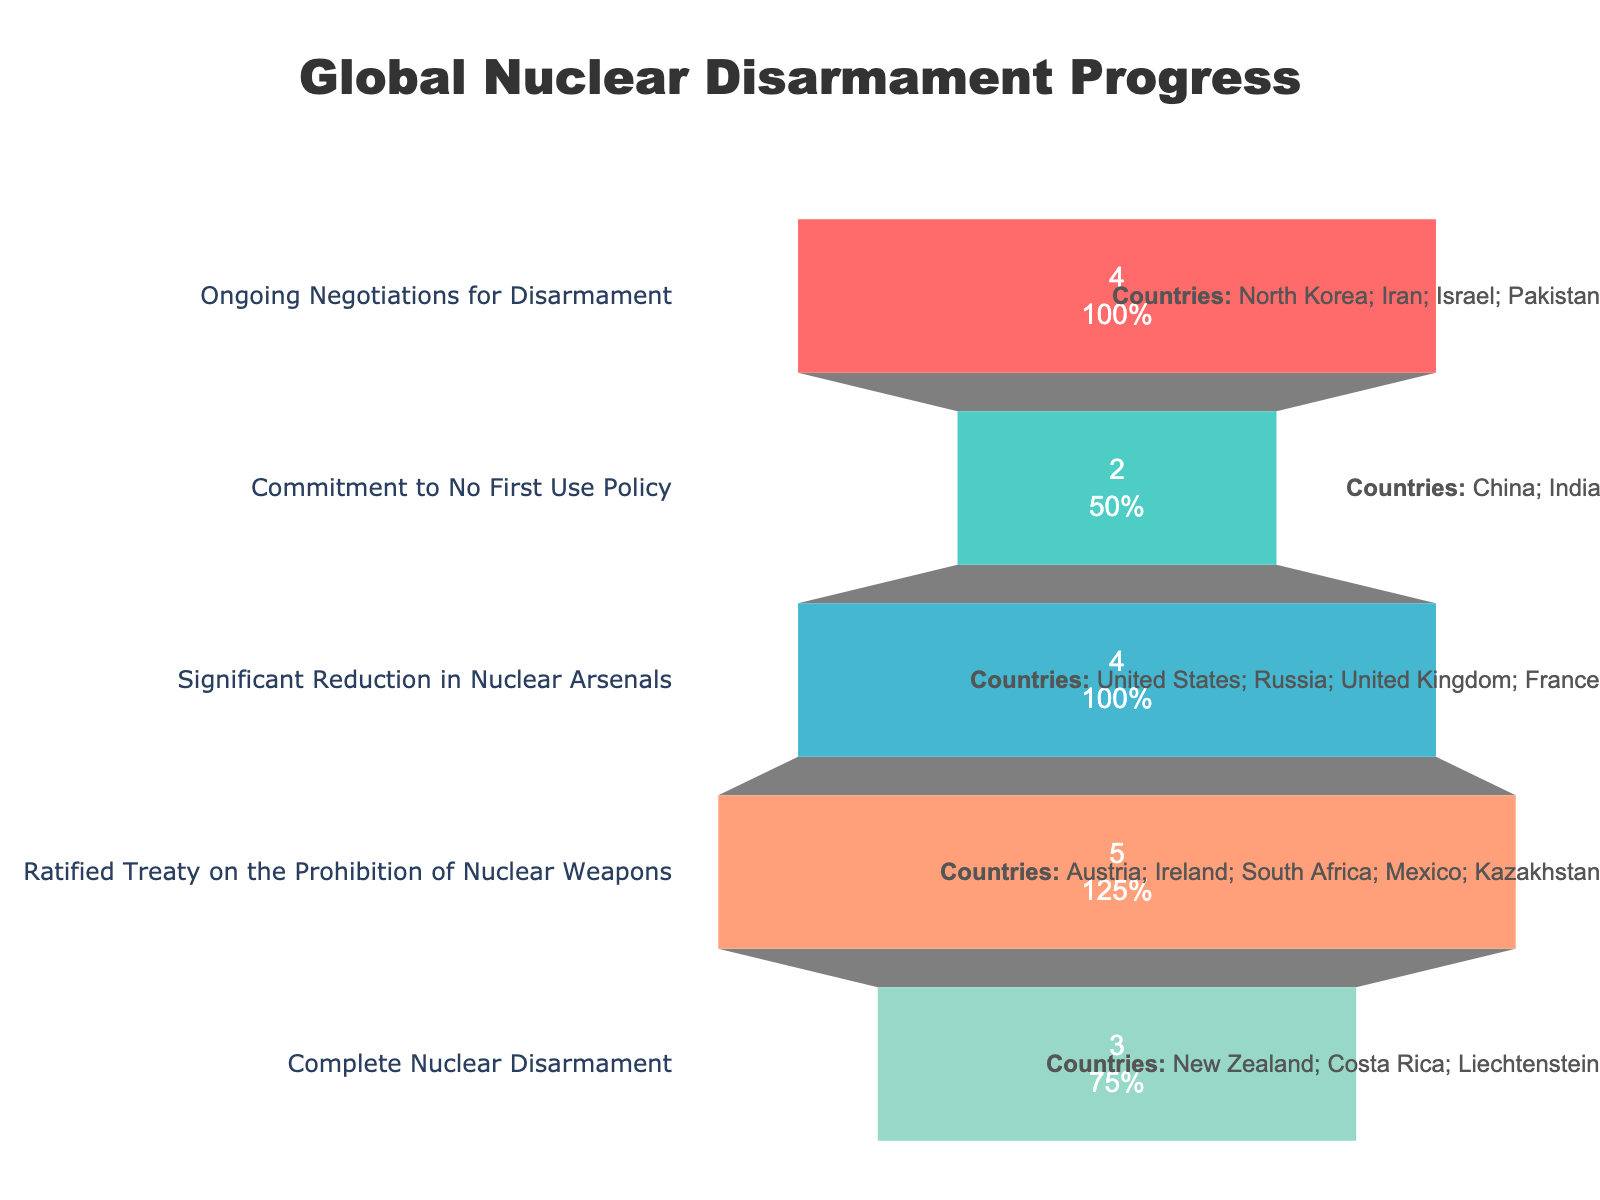How many countries are involved in complete nuclear disarmament? The figure shows a section labeled "Complete Nuclear Disarmament" with the number "3" inside it, indicating the number of countries.
Answer: 3 Which stage has the highest number of countries involved? The funnel chart stages display the number of countries involved in each stage. "Ratified Treaty on the Prohibition of Nuclear Weapons" has the largest number at 5.
Answer: Ratified Treaty on the Prohibition of Nuclear Weapons What is the total number of countries depicted in the funnel chart? Add the numbers of countries in all the stages: 3 (Complete) + 5 (Ratified Treaty) + 4 (Significant Reduction) + 2 (No First Use) + 4 (Ongoing Negotiations) equals 18.
Answer: 18 Are there more countries involved in ongoing negotiations for disarmament or in committing to a no-first-use policy? The figure shows that 4 countries are in "Ongoing Negotiations for Disarmament" while 2 countries are committed to "No First Use Policy". So, ongoing negotiations involve more countries.
Answer: Ongoing Negotiations for Disarmament How many countries have undertaken significant reduction in nuclear arsenals? The section labeled "Significant Reduction in Nuclear Arsenals" shows the number "4" inside it, indicating the number of countries.
Answer: 4 Which stage immediately precedes the 'Commitment to No First Use Policy' in the funnel chart? In a funnel chart, the stages are layered. The stage just above "Commitment to No First Use Policy" is "Significant Reduction in Nuclear Arsenals".
Answer: Significant Reduction in Nuclear Arsenals Is there any stage with an equal number of countries involved as the stage for significant reduction in nuclear arsenals? If so, which one? Both "Significant Reduction in Nuclear Arsenals" and "Ongoing Negotiations for Disarmament" involve 4 countries each as shown in the figure.
Answer: Yes, Ongoing Negotiations for Disarmament Compare the sum of countries involved in the top two stages to those in the bottom three stages. Which is higher? The top two stages are "Complete Nuclear Disarmament" (3) and "Ratified Treaty" (5), summing to 8. The bottom three are "Significant Reduction" (4), "No First Use" (2), and "Ongoing Negotiations" (4), summing to 10. Thus, the bottom three stages involve more countries.
Answer: Bottom three stages Which stages have only one country represented? By visually inspecting each section of the funnel chart, none of the stages show a single country; all sections represent multiple countries.
Answer: None 